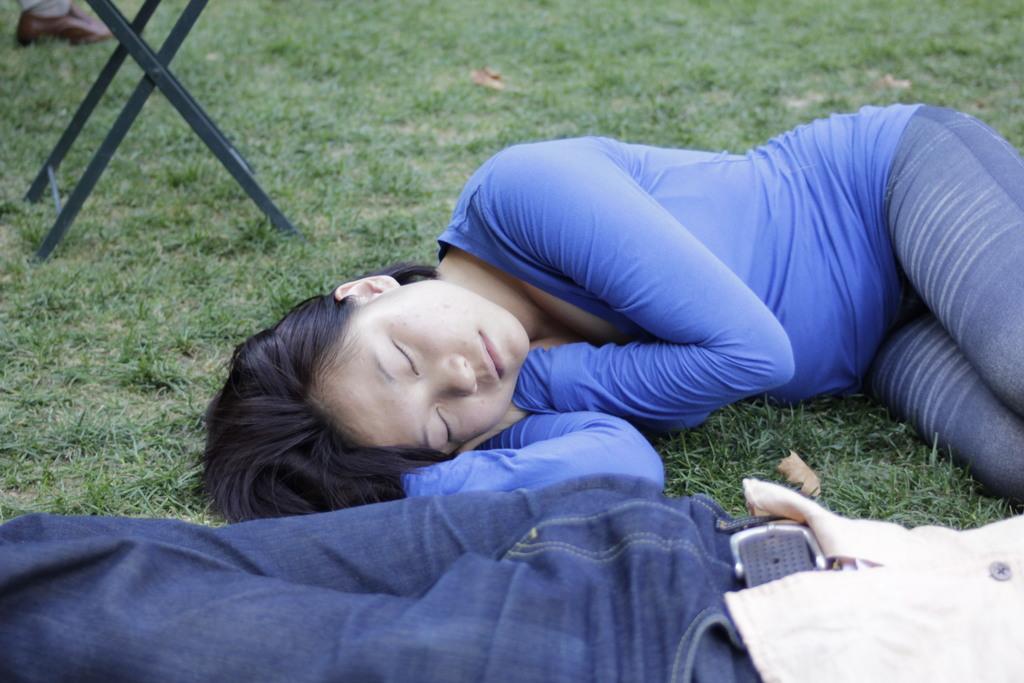Please provide a concise description of this image. In this image, we can see two people lying on the grass and we can see a table. 